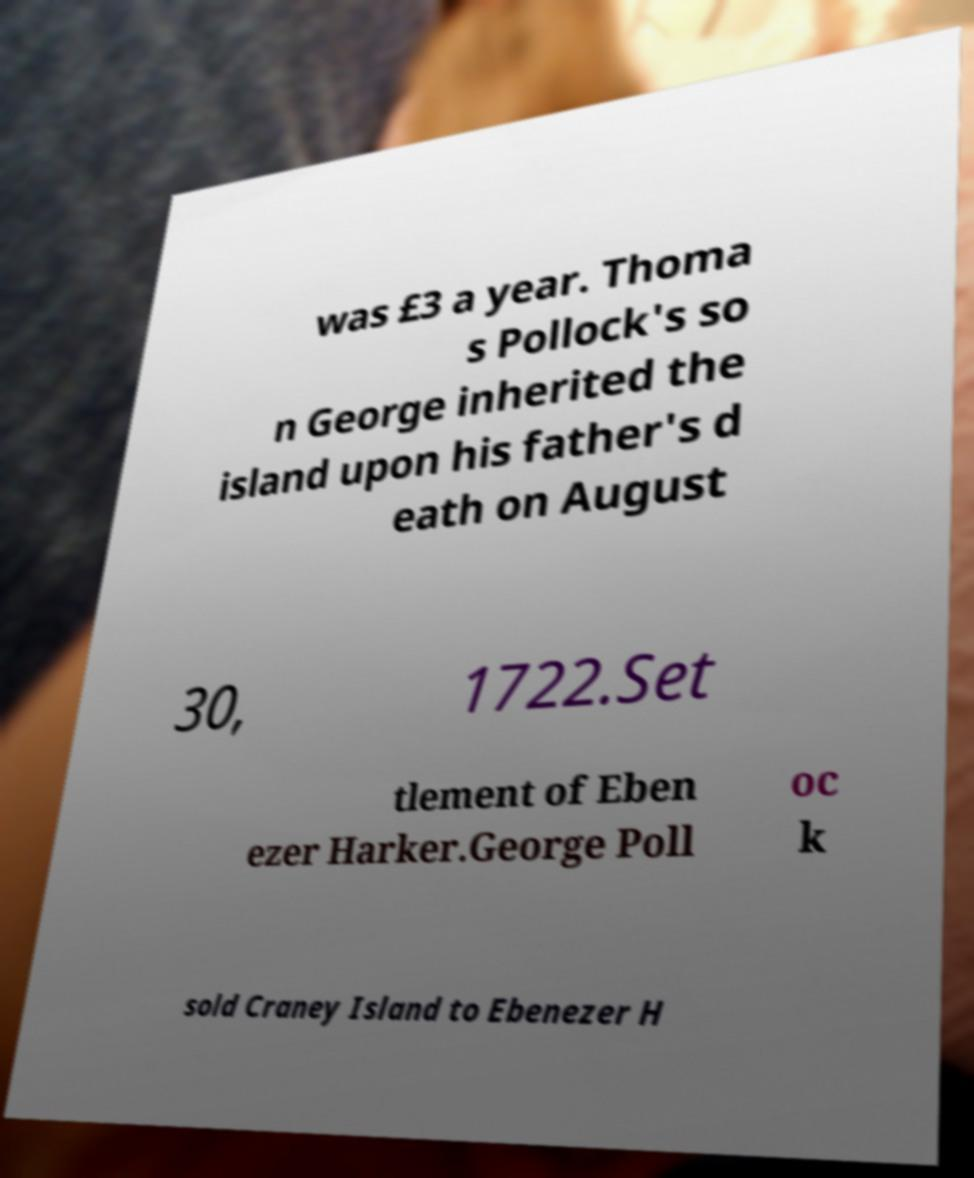For documentation purposes, I need the text within this image transcribed. Could you provide that? was £3 a year. Thoma s Pollock's so n George inherited the island upon his father's d eath on August 30, 1722.Set tlement of Eben ezer Harker.George Poll oc k sold Craney Island to Ebenezer H 